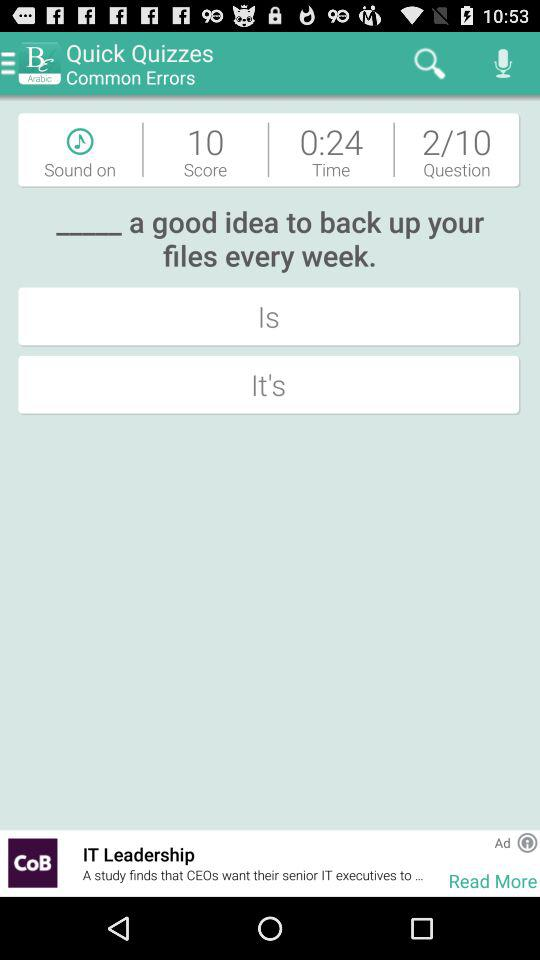What is the score? The score is 10. 